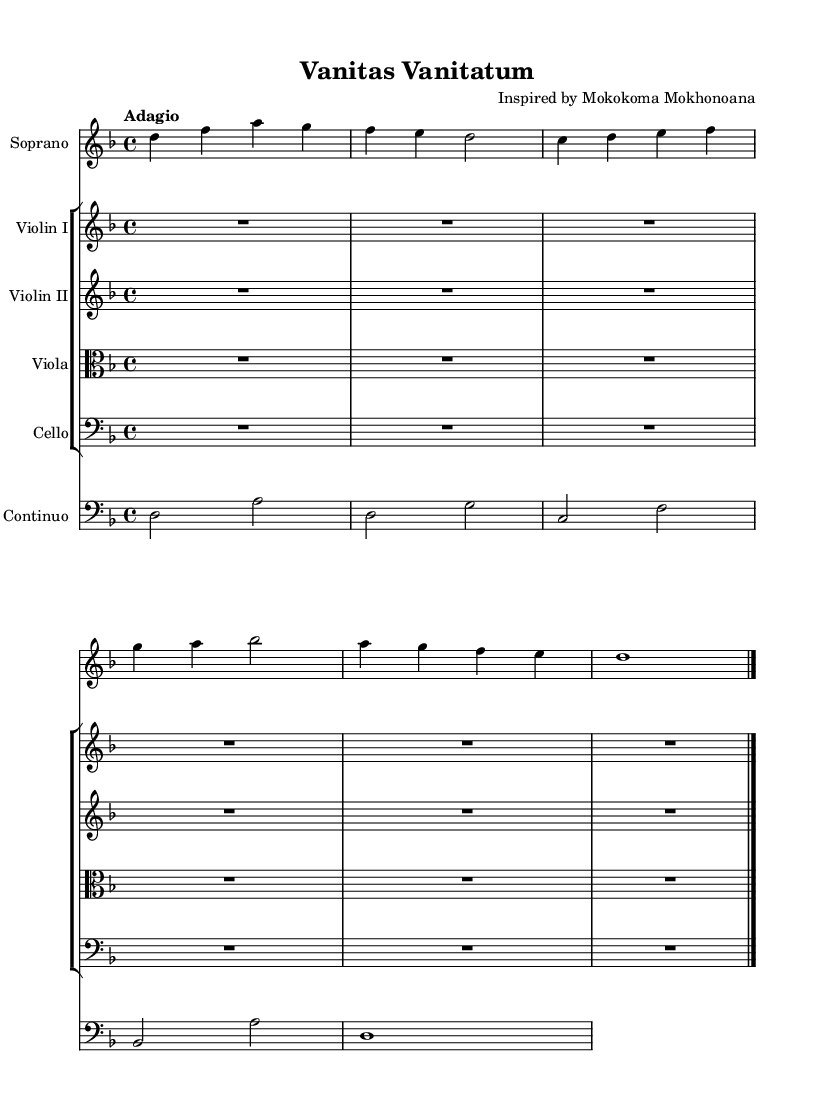What is the key signature of this music? The key signature is d minor, which has one flat. You can verify this by looking at the key signature indicated at the beginning of the staff, immediately following the treble clef symbol.
Answer: d minor What is the time signature of this music? The time signature is four-four. This is shown just after the key signature, indicated by the numbers 4 and 4, which signify four beats in each measure.
Answer: four-four What is the tempo marking of this music? The tempo marking is adagio. This is noted at the beginning of the piece, indicating that the music should be played slowly.
Answer: adagio How many measures are in the soprano part? There are six measures in the soprano part, which can be counted by analyzing the vertical lines that segment the music into measures, ensuring to note any measures that may be partially filled or rest.
Answer: six What type of composition is "Vanitas Vanitatum"? This piece is a cantata. This is inferred from the context of Baroque music styles, where cantatas often explore existential themes and are characterized by vocal music with instrumental accompaniment.
Answer: cantata What is the vocal range of the featured soloist? The featured soloist is a soprano, which can be identified from the label under the staff designated for the soprano part, indicating that it is written for a higher female voice.
Answer: soprano What philosophical theme is explored in the lyrics of this cantata? The theme explored is vanity. This is visible in the lyrics provided, which reflect on the concept of vanity in life, specifically denoting "Vanitas Vanitatum, all is vanity."
Answer: vanity 